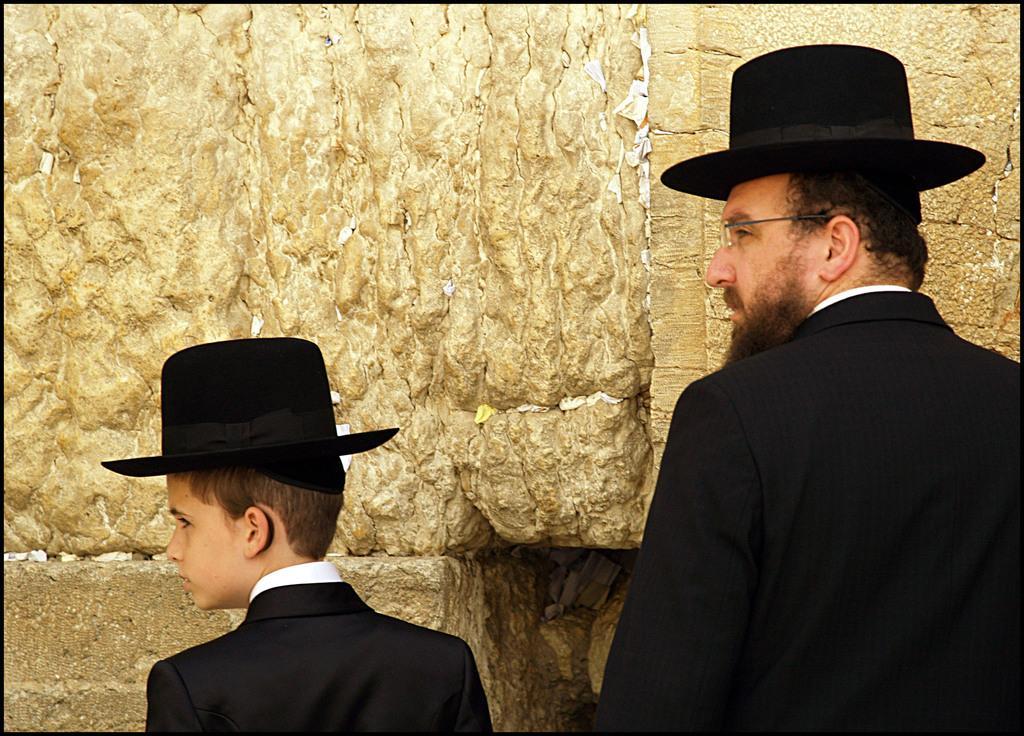How would you summarize this image in a sentence or two? There are two people standing and wore black hats,in front of this people we can see wall. 